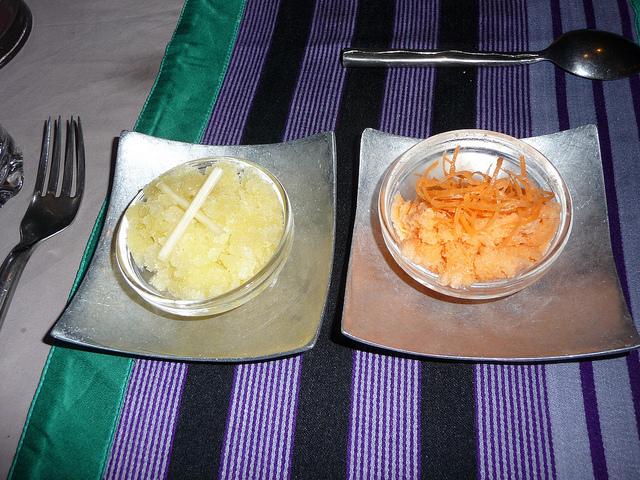How many plates are there?
Write a very short answer. 2. Are these salads?
Answer briefly. No. What kind of food is on the left?
Quick response, please. Rice. 